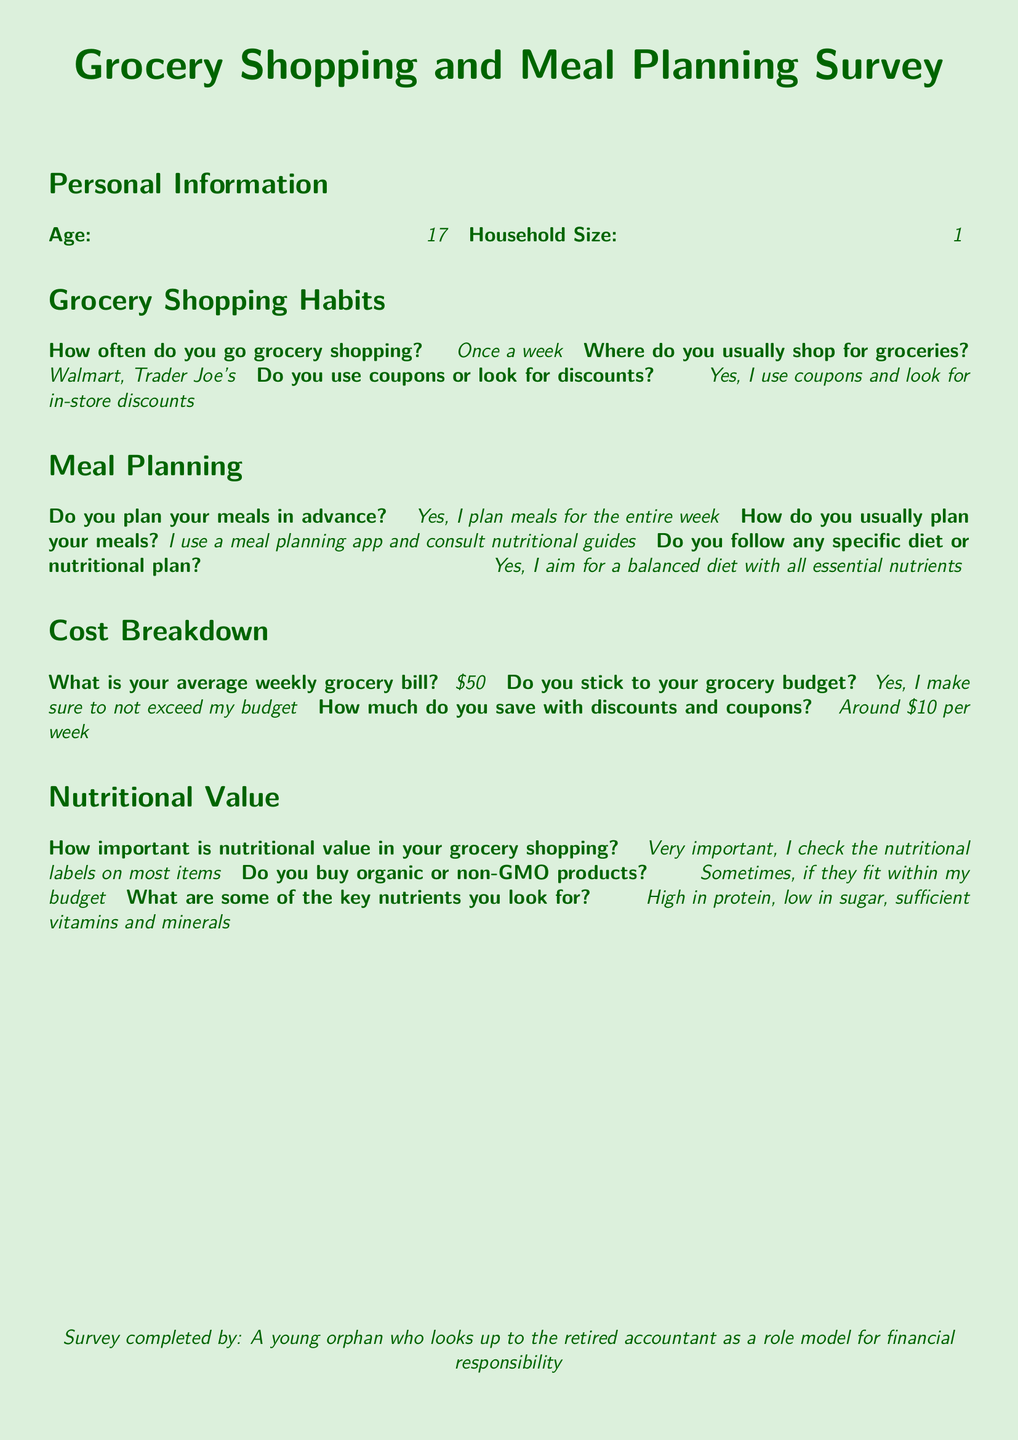What is the age of the responder? The responder's age is stated in the personal information section of the document.
Answer: 17 How many people are in the household? The household size is specified in the personal information section of the document.
Answer: 1 How often does the responder go grocery shopping? This information is found in the grocery shopping habits section.
Answer: Once a week What is the average weekly grocery bill? The average weekly grocery bill is provided in the cost breakdown section of the document.
Answer: $50 How much does the responder save with discounts and coupons? The amount saved is indicated in the cost breakdown section.
Answer: Around $10 per week Why does the responder plan meals in advance? The document indicates the responder's reasoning for meal planning based on their shopping habits.
Answer: To have a structured grocery shopping approach What types of stores does the responder shop at? The names of the stores are listed in the grocery shopping habits section.
Answer: Walmart, Trader Joe's What key nutrients does the responder look for? This information is found in the nutritional value section of the document.
Answer: High in protein, low in sugar, sufficient vitamins and minerals Does the responder use coupons? The grocery shopping habits section specifies whether coupons are used.
Answer: Yes, I use coupons and look for in-store discounts 